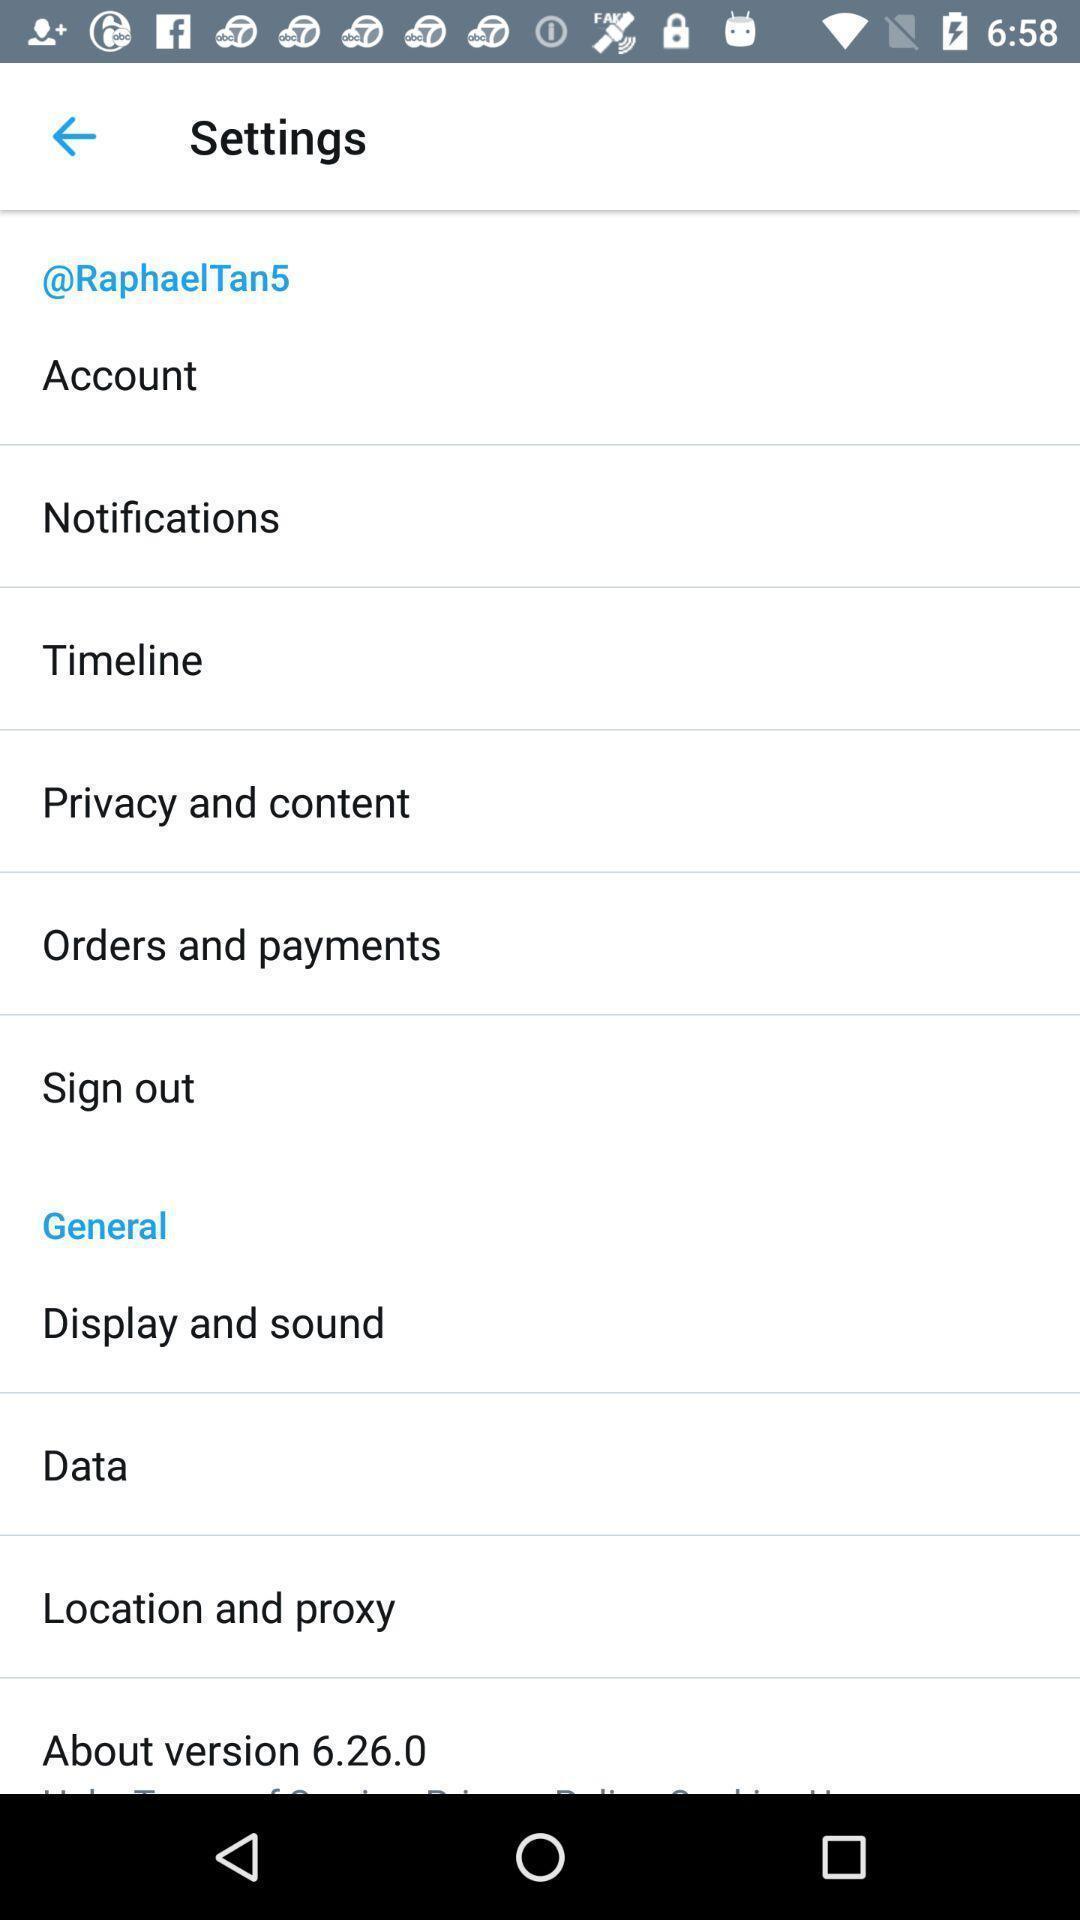Give me a narrative description of this picture. Settings page displaying. 